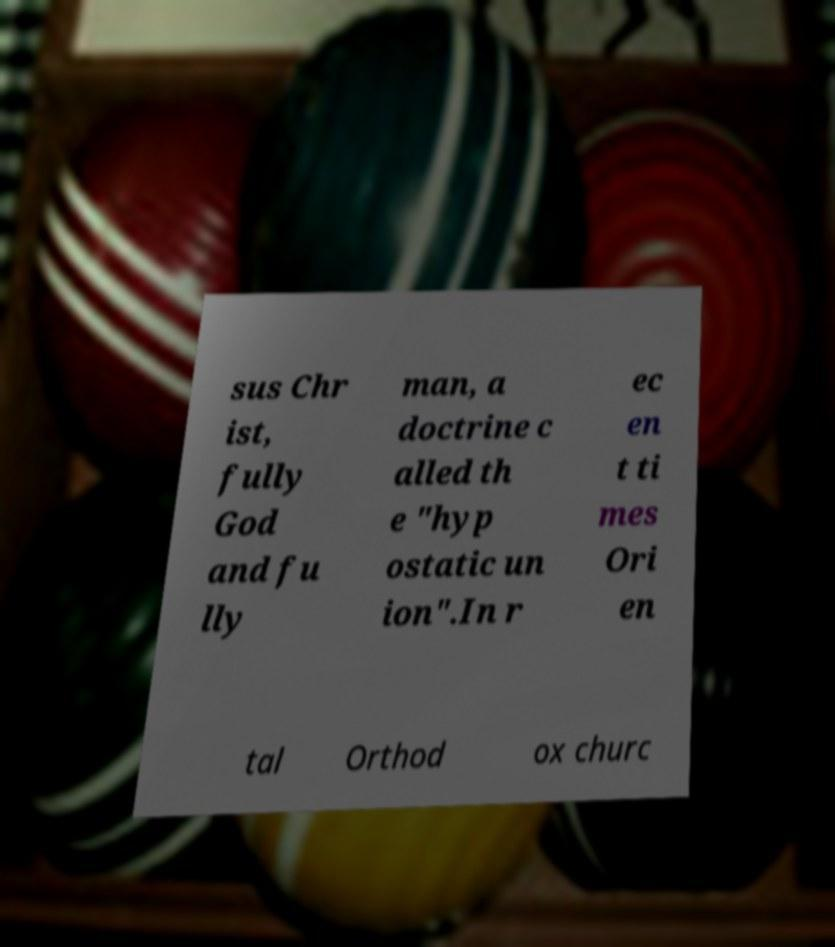There's text embedded in this image that I need extracted. Can you transcribe it verbatim? sus Chr ist, fully God and fu lly man, a doctrine c alled th e "hyp ostatic un ion".In r ec en t ti mes Ori en tal Orthod ox churc 